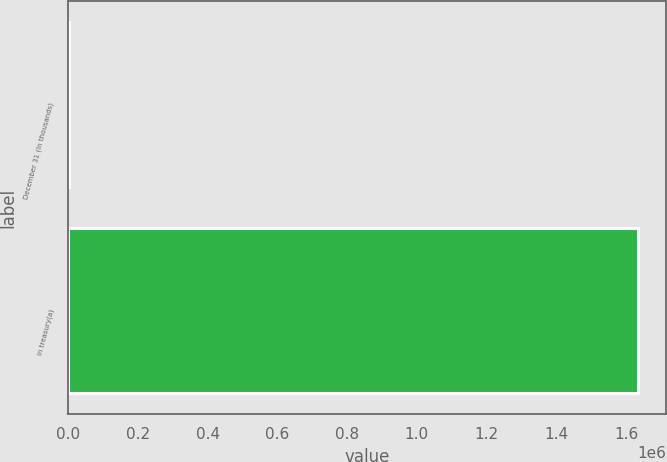<chart> <loc_0><loc_0><loc_500><loc_500><bar_chart><fcel>December 31 (In thousands)<fcel>In treasury(a)<nl><fcel>2013<fcel>1.63296e+06<nl></chart> 